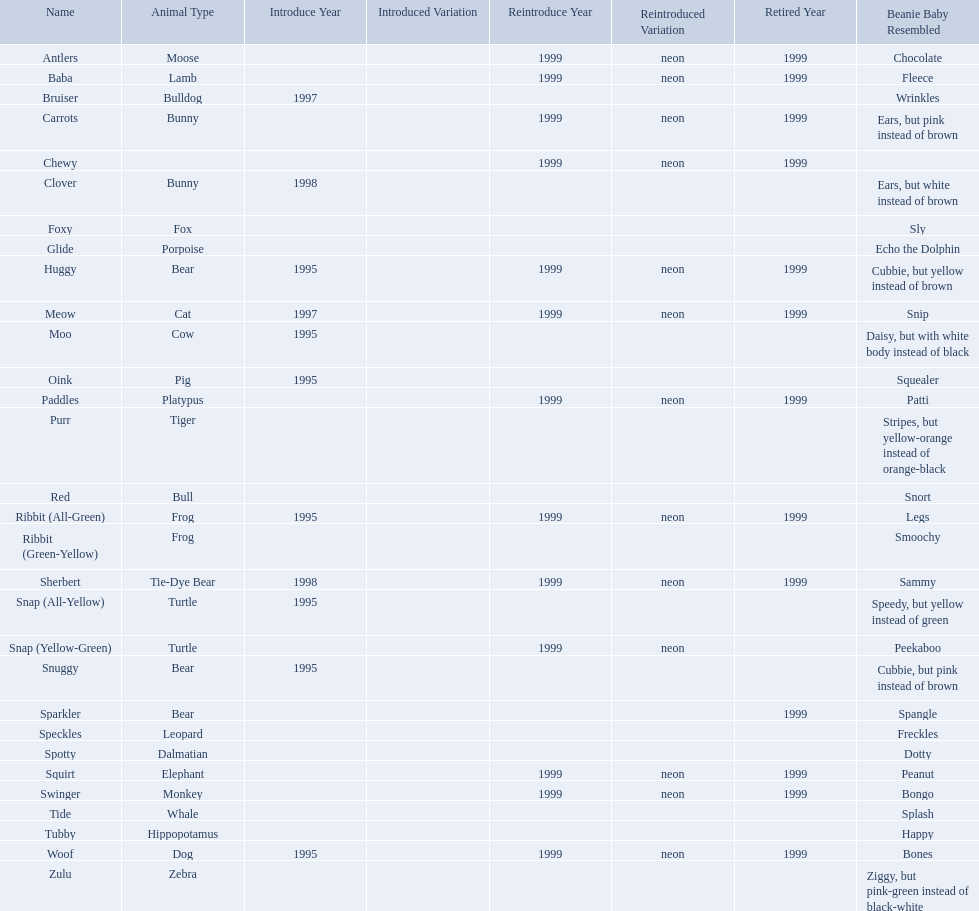What are the types of pillow pal animals? Antlers, Moose, Lamb, Bulldog, Bunny, , Bunny, Fox, Porpoise, Bear, Cat, Cow, Pig, Platypus, Tiger, Bull, Frog, Frog, Tie-Dye Bear, Turtle, Turtle, Bear, Bear, Leopard, Dalmatian, Elephant, Monkey, Whale, Hippopotamus, Dog, Zebra. Of those, which is a dalmatian? Dalmatian. What is the name of the dalmatian? Spotty. What animals are pillow pals? Moose, Lamb, Bulldog, Bunny, Bunny, Fox, Porpoise, Bear, Cat, Cow, Pig, Platypus, Tiger, Bull, Frog, Frog, Tie-Dye Bear, Turtle, Turtle, Bear, Bear, Leopard, Dalmatian, Elephant, Monkey, Whale, Hippopotamus, Dog, Zebra. What is the name of the dalmatian? Spotty. What are all the pillow pals? Antlers, Baba, Bruiser, Carrots, Chewy, Clover, Foxy, Glide, Huggy, Meow, Moo, Oink, Paddles, Purr, Red, Ribbit (All-Green), Ribbit (Green-Yellow), Sherbert, Snap (All-Yellow), Snap (Yellow-Green), Snuggy, Sparkler, Speckles, Spotty, Squirt, Swinger, Tide, Tubby, Woof, Zulu. Which is the only without a listed animal type? Chewy. 